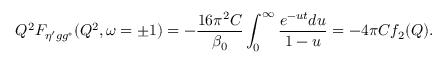<formula> <loc_0><loc_0><loc_500><loc_500>Q ^ { 2 } F _ { \eta ^ { \prime } g g ^ { * } } ( Q ^ { 2 } , \omega = \pm 1 ) = - \frac { 1 6 \pi ^ { 2 } C } { \beta _ { 0 } } \int _ { 0 } ^ { \infty } \frac { e ^ { - u t } d u } { 1 - u } = - 4 \pi C f _ { 2 } ( Q ) .</formula> 